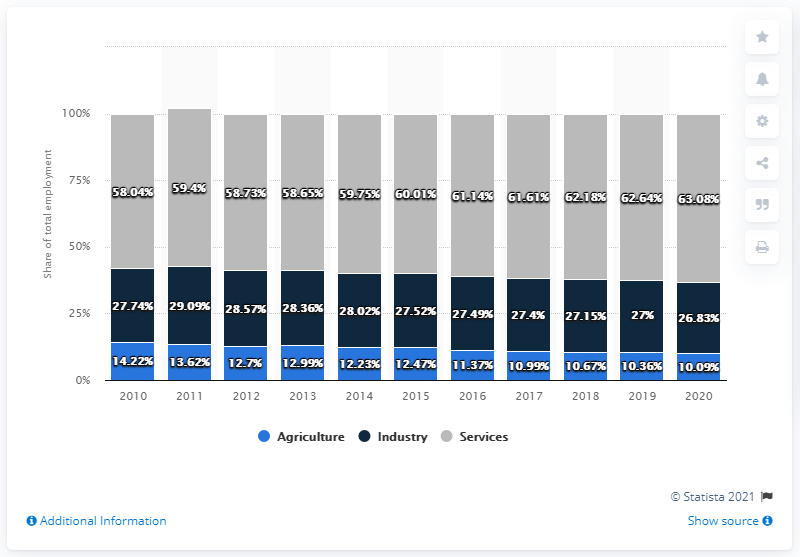Give some essential details in this illustration. In 2020, the percentage of agricultural employment in Malaysia was 10.09%. 